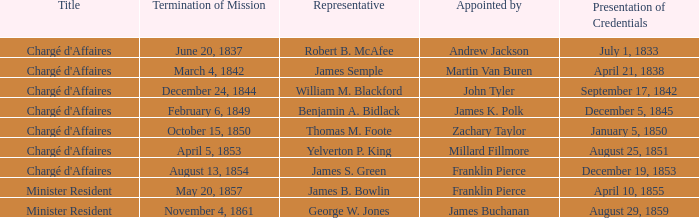What's the Representative listed that has a Presentation of Credentials of August 25, 1851? Yelverton P. King. 